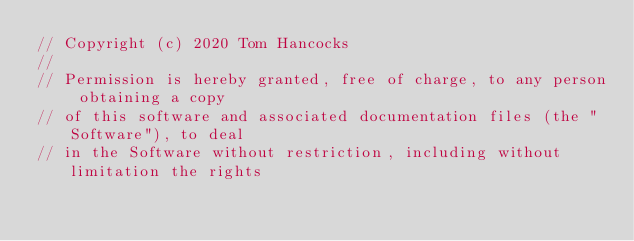<code> <loc_0><loc_0><loc_500><loc_500><_C++_>// Copyright (c) 2020 Tom Hancocks
//
// Permission is hereby granted, free of charge, to any person obtaining a copy
// of this software and associated documentation files (the "Software"), to deal
// in the Software without restriction, including without limitation the rights</code> 